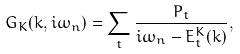<formula> <loc_0><loc_0><loc_500><loc_500>G _ { K } ( k , i \omega _ { n } ) = \sum _ { t } \frac { P _ { t } } { i \omega _ { n } - E ^ { K } _ { t } ( k ) } ,</formula> 